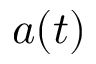<formula> <loc_0><loc_0><loc_500><loc_500>a ( t )</formula> 